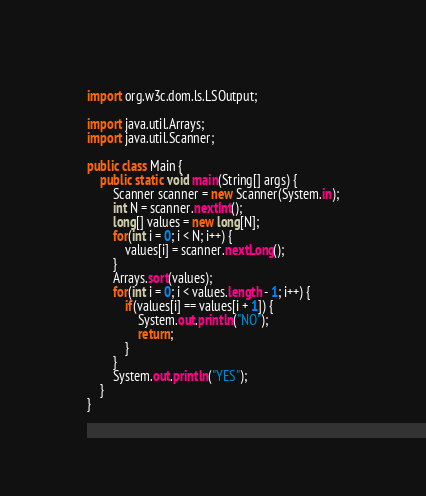Convert code to text. <code><loc_0><loc_0><loc_500><loc_500><_Java_>import org.w3c.dom.ls.LSOutput;

import java.util.Arrays;
import java.util.Scanner;

public class Main {
    public static void main(String[] args) {
        Scanner scanner = new Scanner(System.in);
        int N = scanner.nextInt();
        long[] values = new long[N];
        for(int i = 0; i < N; i++) {
            values[i] = scanner.nextLong();
        }
        Arrays.sort(values);
        for(int i = 0; i < values.length - 1; i++) {
            if(values[i] == values[i + 1]) {
                System.out.println("NO");
                return;
            }
        }
        System.out.println("YES");
    }
}
</code> 